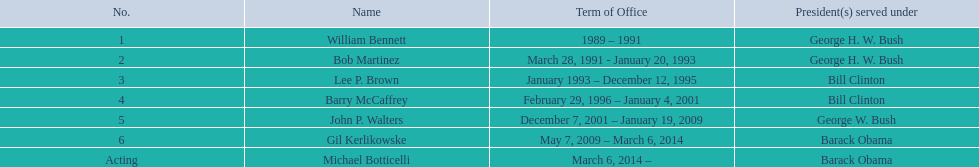When did john p. walters conclude his term? January 19, 2009. Give me the full table as a dictionary. {'header': ['No.', 'Name', 'Term of Office', 'President(s) served under'], 'rows': [['1', 'William Bennett', '1989 – 1991', 'George H. W. Bush'], ['2', 'Bob Martinez', 'March 28, 1991 - January 20, 1993', 'George H. W. Bush'], ['3', 'Lee P. Brown', 'January 1993 – December 12, 1995', 'Bill Clinton'], ['4', 'Barry McCaffrey', 'February 29, 1996 – January 4, 2001', 'Bill Clinton'], ['5', 'John P. Walters', 'December 7, 2001 – January 19, 2009', 'George W. Bush'], ['6', 'Gil Kerlikowske', 'May 7, 2009 – March 6, 2014', 'Barack Obama'], ['Acting', 'Michael Botticelli', 'March 6, 2014 –', 'Barack Obama']]} 